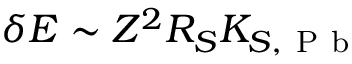<formula> <loc_0><loc_0><loc_500><loc_500>\delta E \sim Z ^ { 2 } R _ { S } K _ { S , P b }</formula> 